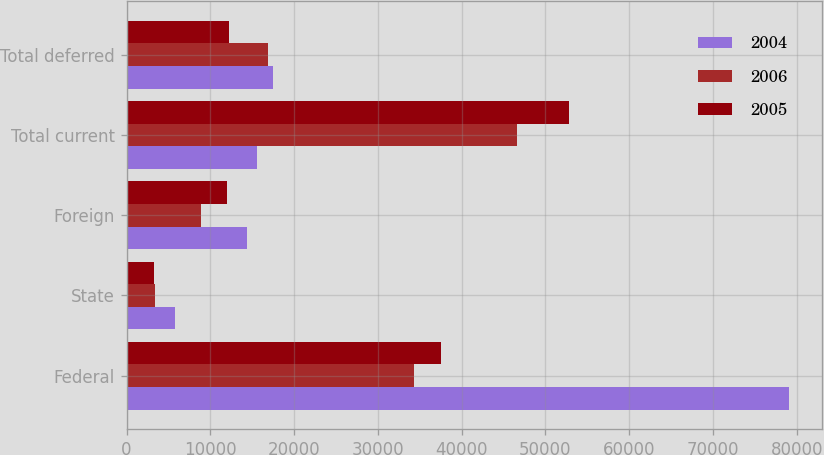<chart> <loc_0><loc_0><loc_500><loc_500><stacked_bar_chart><ecel><fcel>Federal<fcel>State<fcel>Foreign<fcel>Total current<fcel>Total deferred<nl><fcel>2004<fcel>79082<fcel>5837<fcel>14381<fcel>15625<fcel>17516<nl><fcel>2006<fcel>34320<fcel>3436<fcel>8858<fcel>46614<fcel>16869<nl><fcel>2005<fcel>37580<fcel>3268<fcel>11974<fcel>52822<fcel>12188<nl></chart> 